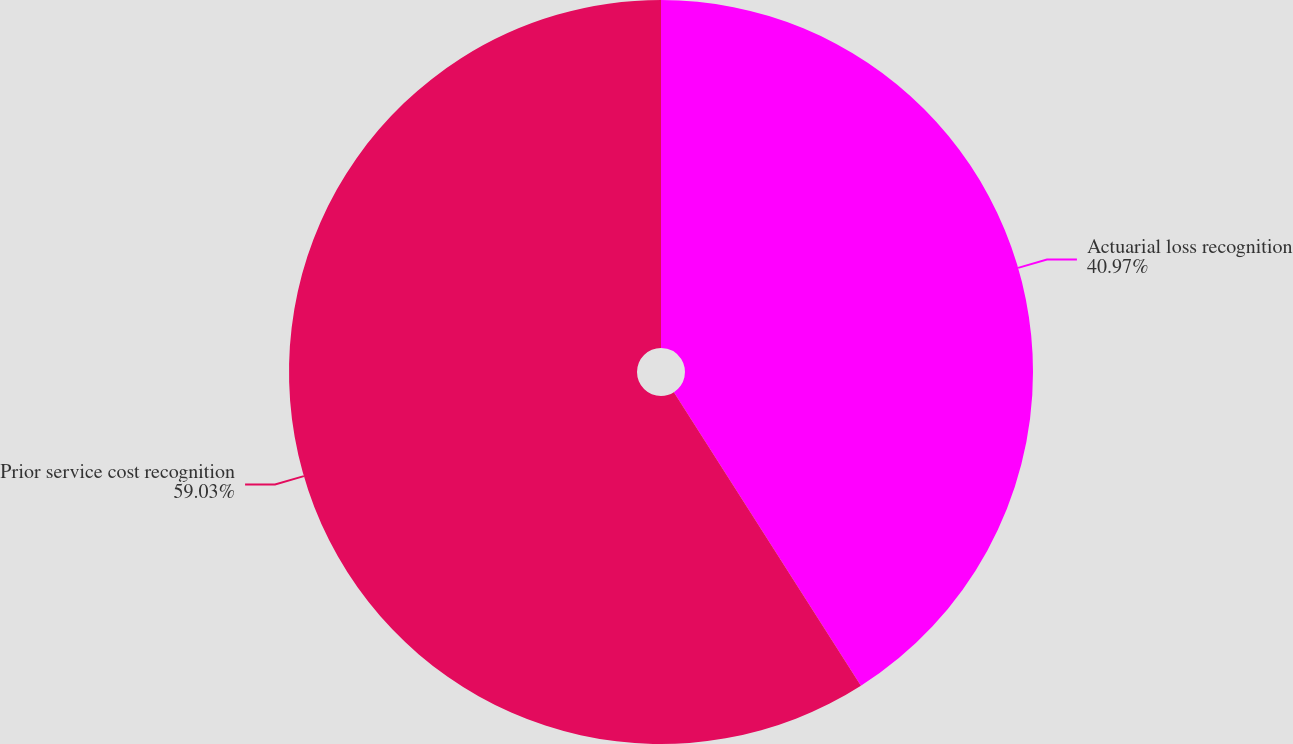<chart> <loc_0><loc_0><loc_500><loc_500><pie_chart><fcel>Actuarial loss recognition<fcel>Prior service cost recognition<nl><fcel>40.97%<fcel>59.03%<nl></chart> 